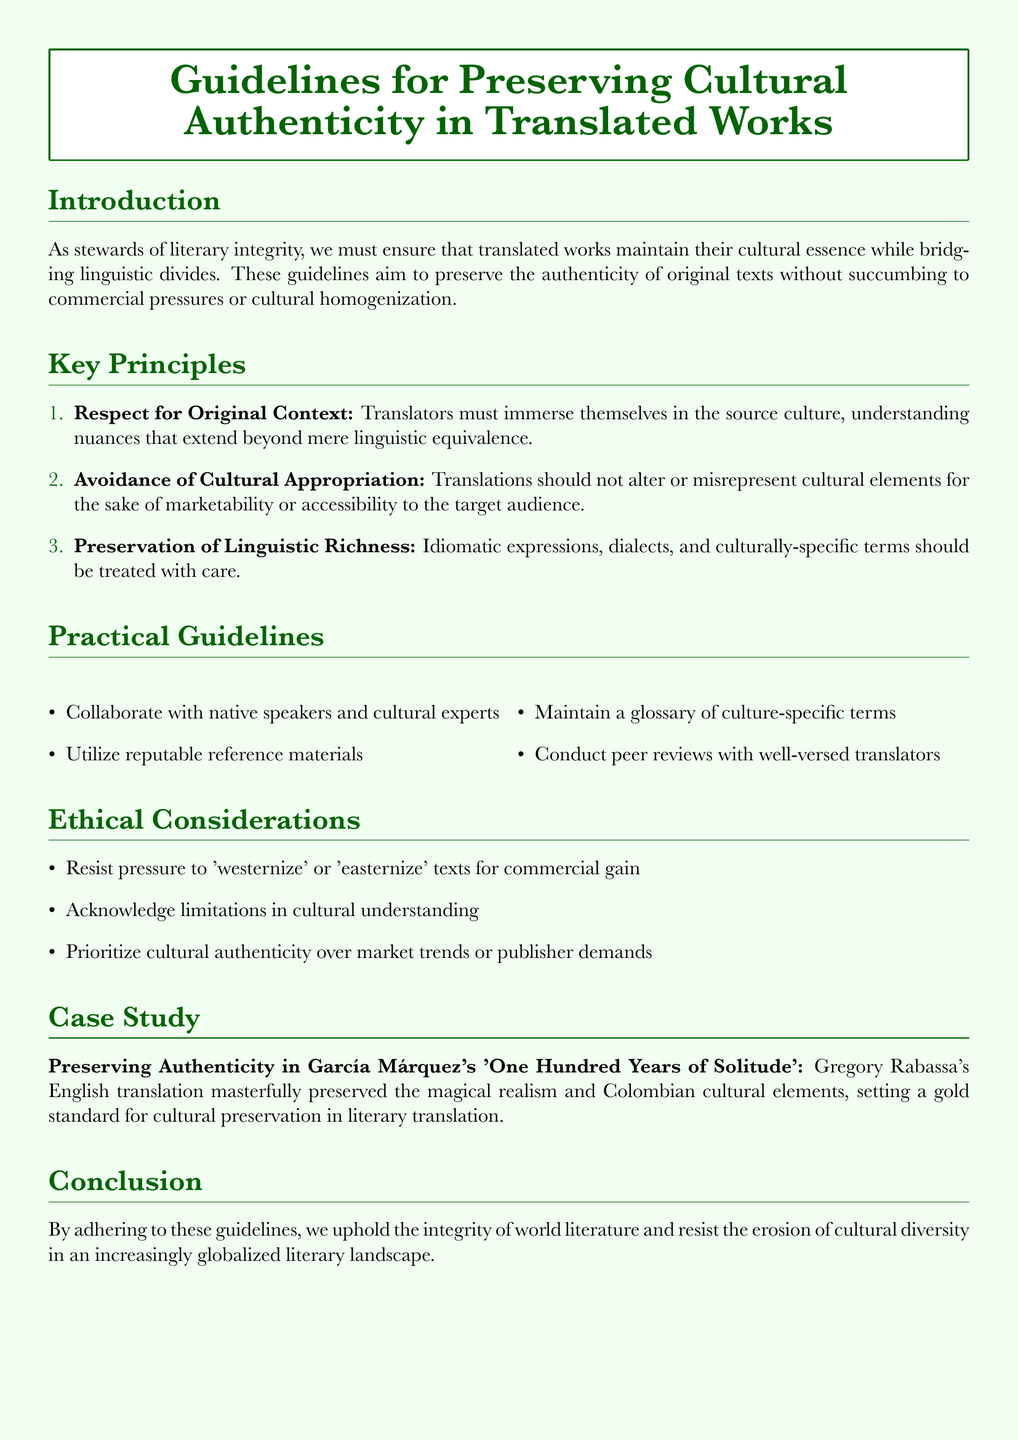What is the title of the document? The title of the document is presented prominently in a tcolorbox at the start of the document.
Answer: Guidelines for Preserving Cultural Authenticity in Translated Works What is the first key principle listed? The first key principle is stated under the key principles section.
Answer: Respect for Original Context How many practical guidelines are provided? The number of practical guidelines is derived from counting the bullet points in the practical guidelines section.
Answer: Four What should translators prioritize according to ethical considerations? This information is stated in the ethical considerations section, highlighting their priorities.
Answer: Cultural authenticity Who is the case study about? The case study references a well-known author and his notable work.
Answer: García Márquez What is the color of the document's background? The background color is specified in the document's setup.
Answer: Light green What is the last section of the document? The last section concludes the document's discussion and is labeled at the very end.
Answer: Conclusion 